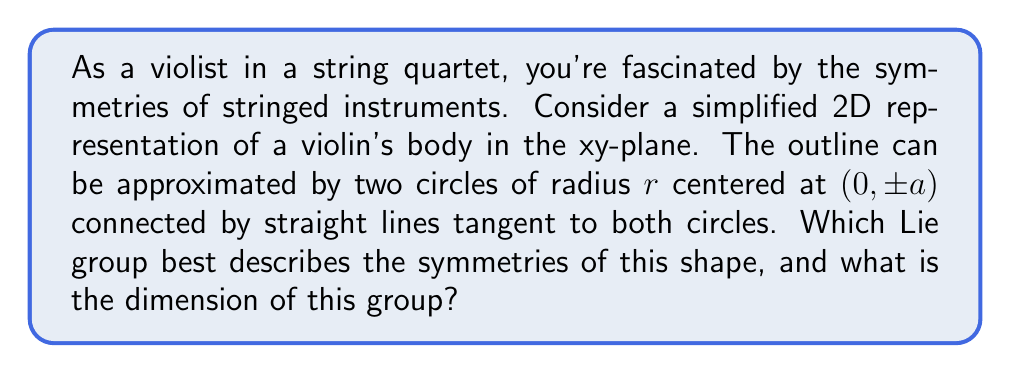Give your solution to this math problem. Let's approach this step-by-step:

1) First, we need to identify the symmetries of the simplified violin shape:
   - Reflection across the x-axis
   - Rotation by 180° around the origin
   - These two operations generate all symmetries of the shape

2) The group of symmetries is isomorphic to $\mathbb{Z}_2 \times \mathbb{Z}_2$, where $\mathbb{Z}_2$ is the cyclic group of order 2.

3) However, we're asked about Lie groups. The discrete group $\mathbb{Z}_2 \times \mathbb{Z}_2$ is not a Lie group because it's not a continuous manifold.

4) To find a Lie group that describes these symmetries, we need to consider a continuous group that contains these discrete symmetries as a subgroup.

5) The orthogonal group $O(2)$ is the smallest Lie group that contains both reflections and rotations in 2D space.

6) The dimension of $O(2)$ is 1, as it can be parameterized by a single real number (the angle of rotation) plus a discrete parameter (whether to include a reflection or not).

7) While $O(2)$ is larger than the actual symmetry group of the violin shape, it's the smallest Lie group that encompasses all the required symmetries.

Therefore, the Lie group that best describes the symmetries of this simplified violin shape is $O(2)$.
Answer: The Lie group that best describes the symmetries of the simplified violin shape is $O(2)$, with dimension 1. 